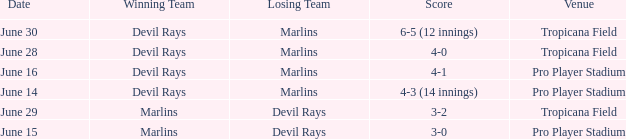What was the score on june 29 when the devil rays los? 3-2. I'm looking to parse the entire table for insights. Could you assist me with that? {'header': ['Date', 'Winning Team', 'Losing Team', 'Score', 'Venue'], 'rows': [['June 30', 'Devil Rays', 'Marlins', '6-5 (12 innings)', 'Tropicana Field'], ['June 28', 'Devil Rays', 'Marlins', '4-0', 'Tropicana Field'], ['June 16', 'Devil Rays', 'Marlins', '4-1', 'Pro Player Stadium'], ['June 14', 'Devil Rays', 'Marlins', '4-3 (14 innings)', 'Pro Player Stadium'], ['June 29', 'Marlins', 'Devil Rays', '3-2', 'Tropicana Field'], ['June 15', 'Marlins', 'Devil Rays', '3-0', 'Pro Player Stadium']]} 